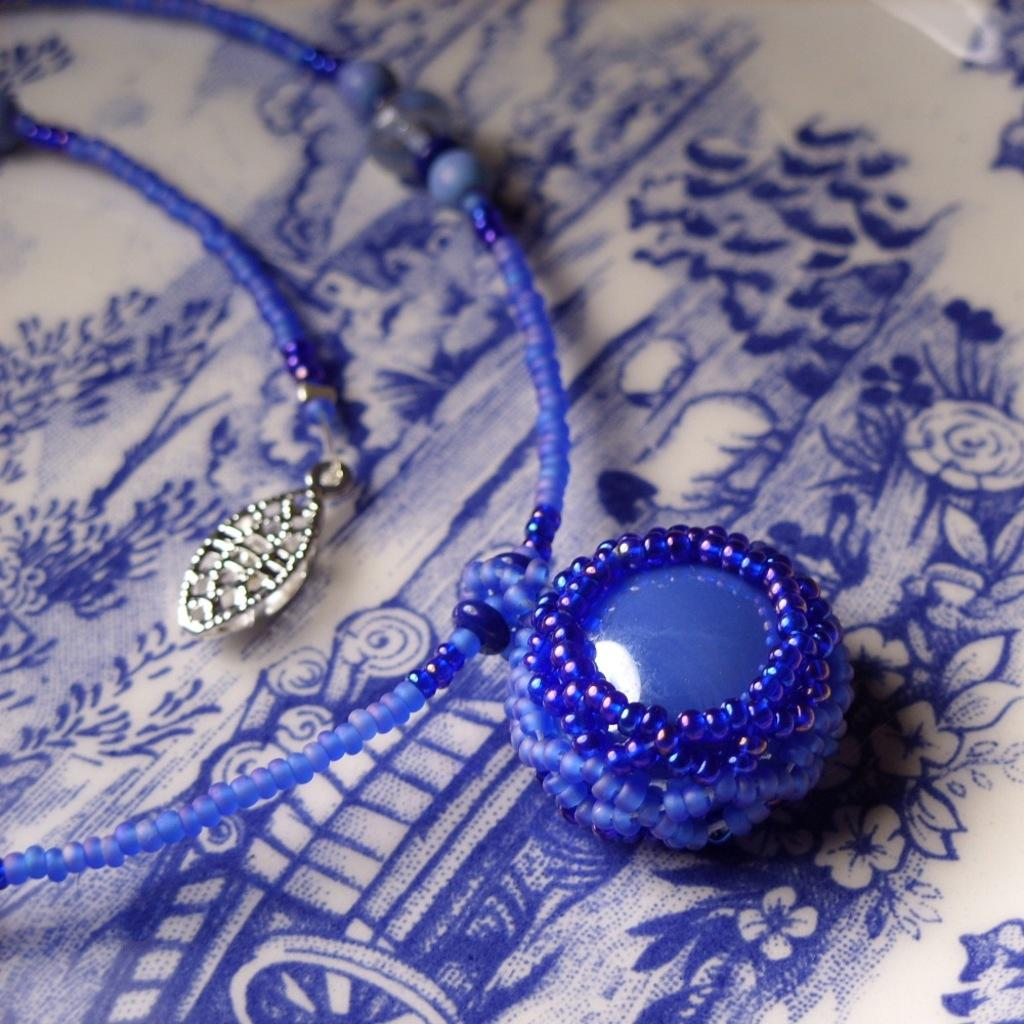What is the color of the jewelry in the image? The jewelry in the image is blue colored. Can you tell me how much milk is being poured into the cable in the image? There is no milk or cable present in the image; it features a blue colored jewelry. What type of mountain is visible in the background of the image? There is no mountain visible in the image; it features a blue colored jewelry. 